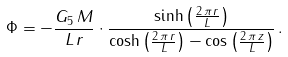<formula> <loc_0><loc_0><loc_500><loc_500>\Phi = - \frac { G _ { 5 } \, M } { L \, r } \cdot \frac { \sinh \left ( \frac { 2 \, \pi \, r } { L } \right ) } { \cosh \left ( \frac { 2 \, \pi \, r } { L } \right ) - \cos \left ( \frac { 2 \, \pi \, z } { L } \right ) } \, .</formula> 